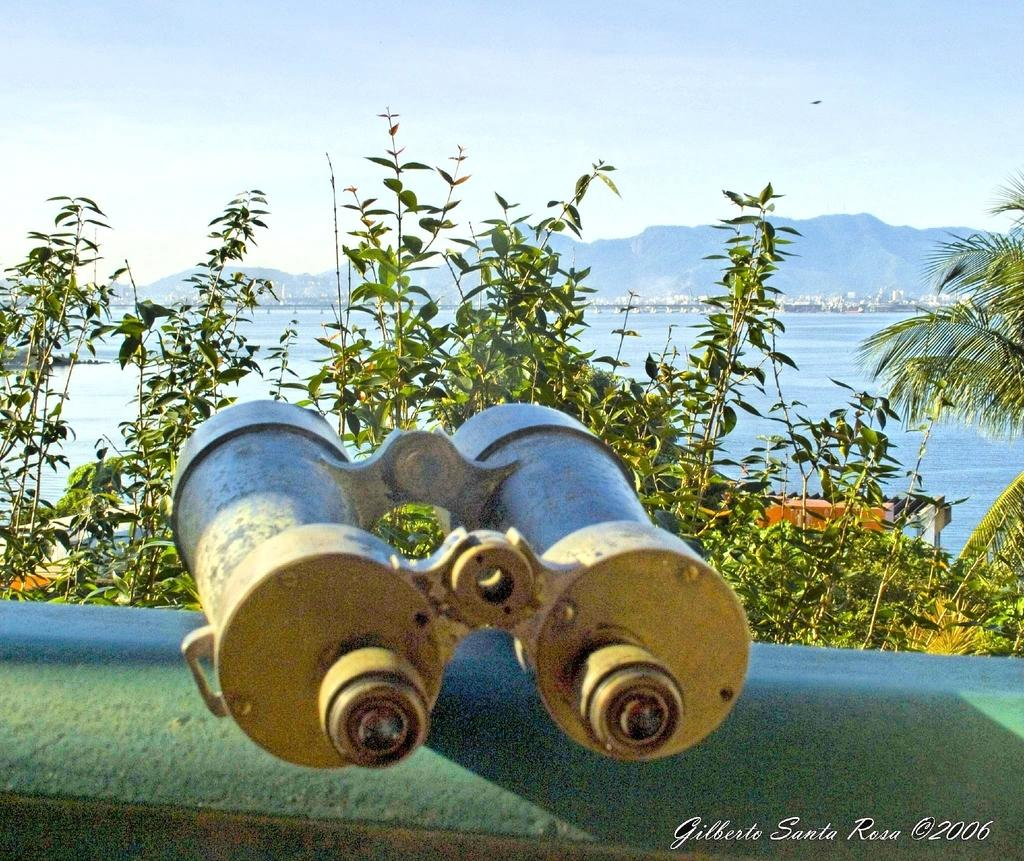What is the main object in the image? There are binoculars in the image. Where are the binoculars located? The binoculars are kept on the wall. What can be seen in the background of the image? There are trees and an ocean visible in the image. What is the governor arguing about with the lip in the image? There is no governor or lip present in the image. 